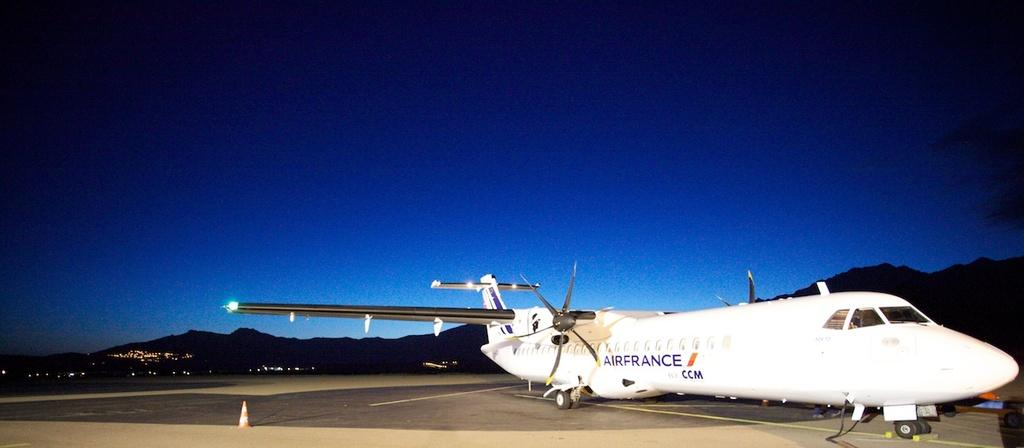Provide a one-sentence caption for the provided image. An Airfrance airplane sitting on the runway with mountains in the background. 